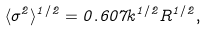Convert formula to latex. <formula><loc_0><loc_0><loc_500><loc_500>\langle \sigma ^ { 2 } \rangle ^ { 1 / 2 } = 0 . 6 0 7 k ^ { 1 / 2 } R ^ { 1 / 2 } ,</formula> 